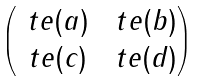<formula> <loc_0><loc_0><loc_500><loc_500>\begin{pmatrix} \ t e ( a ) & \ t e ( b ) \\ \ t e ( c ) & \ t e ( d ) \end{pmatrix}</formula> 